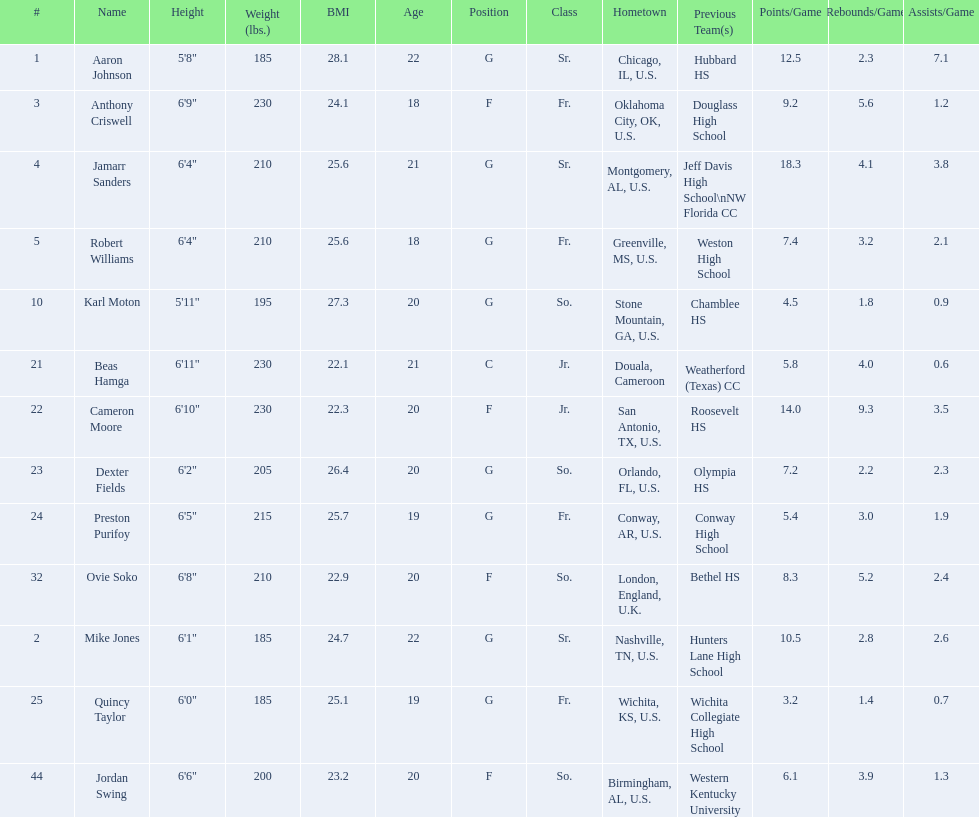What is the average weight of jamarr sanders and robert williams? 210. 